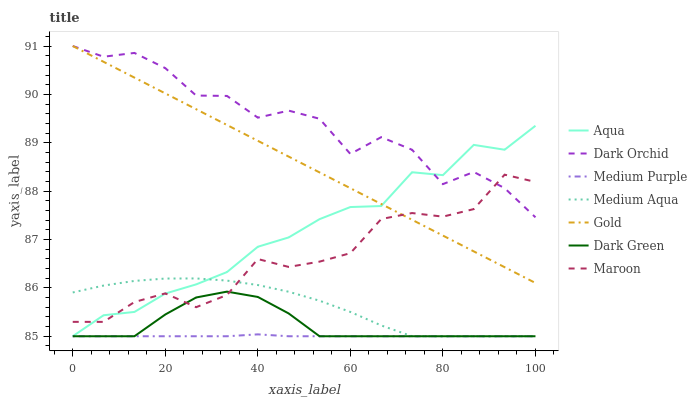Does Aqua have the minimum area under the curve?
Answer yes or no. No. Does Aqua have the maximum area under the curve?
Answer yes or no. No. Is Aqua the smoothest?
Answer yes or no. No. Is Aqua the roughest?
Answer yes or no. No. Does Dark Orchid have the lowest value?
Answer yes or no. No. Does Aqua have the highest value?
Answer yes or no. No. Is Medium Purple less than Maroon?
Answer yes or no. Yes. Is Maroon greater than Medium Purple?
Answer yes or no. Yes. Does Medium Purple intersect Maroon?
Answer yes or no. No. 